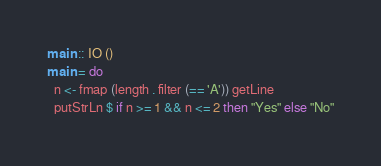<code> <loc_0><loc_0><loc_500><loc_500><_Haskell_>main :: IO ()
main = do
  n <- fmap (length . filter (== 'A')) getLine
  putStrLn $ if n >= 1 && n <= 2 then "Yes" else "No"</code> 